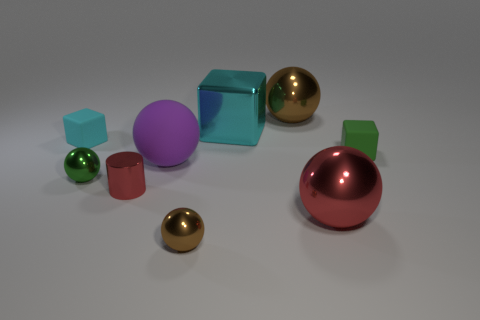What number of spheres are tiny metal objects or large purple objects?
Make the answer very short. 3. What color is the cylinder?
Your answer should be compact. Red. Are there more green rubber objects than rubber blocks?
Offer a terse response. No. What number of things are either large red shiny spheres in front of the large cyan object or gray shiny balls?
Keep it short and to the point. 1. Is the small green ball made of the same material as the tiny cyan block?
Offer a very short reply. No. The red metallic object that is the same shape as the small green metal object is what size?
Your answer should be very brief. Large. Does the red object on the right side of the small metallic cylinder have the same shape as the matte object on the right side of the small brown metallic sphere?
Give a very brief answer. No. There is a green shiny thing; does it have the same size as the brown object behind the tiny red metallic cylinder?
Ensure brevity in your answer.  No. What number of other objects are the same material as the big cyan cube?
Offer a terse response. 5. Is there any other thing that is the same shape as the cyan rubber object?
Offer a very short reply. Yes. 